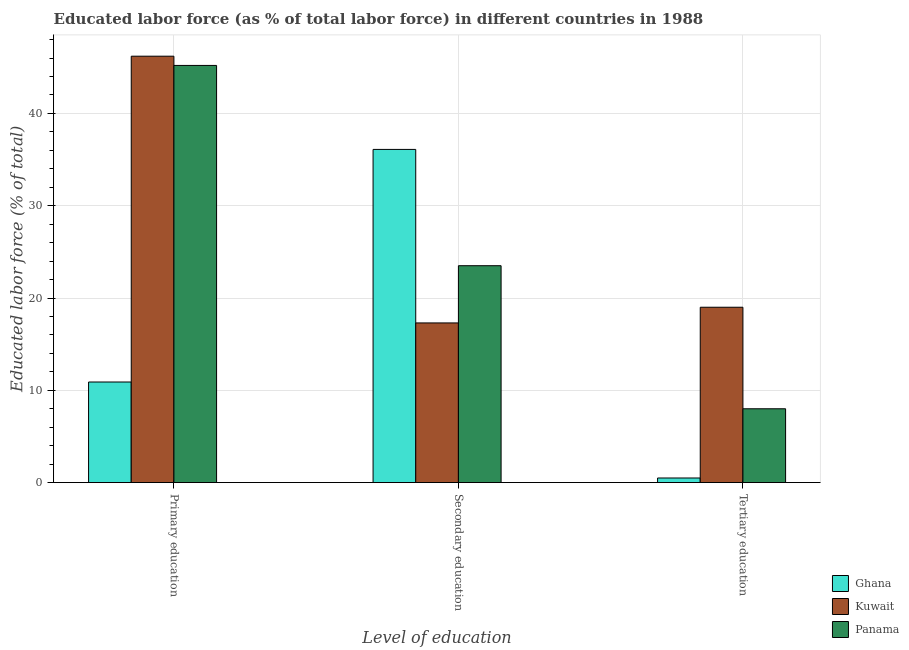How many different coloured bars are there?
Your response must be concise. 3. Are the number of bars per tick equal to the number of legend labels?
Ensure brevity in your answer.  Yes. How many bars are there on the 2nd tick from the left?
Provide a short and direct response. 3. What is the label of the 1st group of bars from the left?
Give a very brief answer. Primary education. What is the percentage of labor force who received primary education in Kuwait?
Offer a very short reply. 46.2. Across all countries, what is the maximum percentage of labor force who received primary education?
Provide a succinct answer. 46.2. Across all countries, what is the minimum percentage of labor force who received tertiary education?
Make the answer very short. 0.5. In which country was the percentage of labor force who received primary education maximum?
Your answer should be very brief. Kuwait. What is the average percentage of labor force who received secondary education per country?
Provide a succinct answer. 25.63. What is the difference between the percentage of labor force who received tertiary education and percentage of labor force who received primary education in Ghana?
Offer a terse response. -10.4. What is the ratio of the percentage of labor force who received primary education in Kuwait to that in Ghana?
Provide a succinct answer. 4.24. Is the percentage of labor force who received primary education in Ghana less than that in Kuwait?
Offer a very short reply. Yes. Is the difference between the percentage of labor force who received secondary education in Kuwait and Panama greater than the difference between the percentage of labor force who received tertiary education in Kuwait and Panama?
Your answer should be very brief. No. What is the difference between the highest and the lowest percentage of labor force who received tertiary education?
Give a very brief answer. 18.5. What does the 2nd bar from the left in Tertiary education represents?
Offer a very short reply. Kuwait. What does the 1st bar from the right in Primary education represents?
Provide a short and direct response. Panama. Are the values on the major ticks of Y-axis written in scientific E-notation?
Your answer should be compact. No. Does the graph contain any zero values?
Provide a succinct answer. No. How many legend labels are there?
Provide a succinct answer. 3. What is the title of the graph?
Provide a succinct answer. Educated labor force (as % of total labor force) in different countries in 1988. What is the label or title of the X-axis?
Ensure brevity in your answer.  Level of education. What is the label or title of the Y-axis?
Provide a short and direct response. Educated labor force (% of total). What is the Educated labor force (% of total) of Ghana in Primary education?
Make the answer very short. 10.9. What is the Educated labor force (% of total) of Kuwait in Primary education?
Offer a very short reply. 46.2. What is the Educated labor force (% of total) of Panama in Primary education?
Your response must be concise. 45.2. What is the Educated labor force (% of total) in Ghana in Secondary education?
Your answer should be very brief. 36.1. What is the Educated labor force (% of total) in Kuwait in Secondary education?
Your answer should be compact. 17.3. What is the Educated labor force (% of total) in Panama in Secondary education?
Your response must be concise. 23.5. Across all Level of education, what is the maximum Educated labor force (% of total) of Ghana?
Your answer should be very brief. 36.1. Across all Level of education, what is the maximum Educated labor force (% of total) of Kuwait?
Your answer should be very brief. 46.2. Across all Level of education, what is the maximum Educated labor force (% of total) in Panama?
Keep it short and to the point. 45.2. Across all Level of education, what is the minimum Educated labor force (% of total) in Kuwait?
Offer a very short reply. 17.3. Across all Level of education, what is the minimum Educated labor force (% of total) in Panama?
Provide a succinct answer. 8. What is the total Educated labor force (% of total) in Ghana in the graph?
Provide a succinct answer. 47.5. What is the total Educated labor force (% of total) in Kuwait in the graph?
Your response must be concise. 82.5. What is the total Educated labor force (% of total) of Panama in the graph?
Give a very brief answer. 76.7. What is the difference between the Educated labor force (% of total) of Ghana in Primary education and that in Secondary education?
Offer a terse response. -25.2. What is the difference between the Educated labor force (% of total) of Kuwait in Primary education and that in Secondary education?
Your answer should be compact. 28.9. What is the difference between the Educated labor force (% of total) in Panama in Primary education and that in Secondary education?
Your answer should be compact. 21.7. What is the difference between the Educated labor force (% of total) in Kuwait in Primary education and that in Tertiary education?
Provide a succinct answer. 27.2. What is the difference between the Educated labor force (% of total) of Panama in Primary education and that in Tertiary education?
Offer a very short reply. 37.2. What is the difference between the Educated labor force (% of total) of Ghana in Secondary education and that in Tertiary education?
Your answer should be very brief. 35.6. What is the difference between the Educated labor force (% of total) of Kuwait in Secondary education and that in Tertiary education?
Offer a terse response. -1.7. What is the difference between the Educated labor force (% of total) of Panama in Secondary education and that in Tertiary education?
Offer a terse response. 15.5. What is the difference between the Educated labor force (% of total) in Kuwait in Primary education and the Educated labor force (% of total) in Panama in Secondary education?
Your answer should be very brief. 22.7. What is the difference between the Educated labor force (% of total) in Kuwait in Primary education and the Educated labor force (% of total) in Panama in Tertiary education?
Offer a very short reply. 38.2. What is the difference between the Educated labor force (% of total) of Ghana in Secondary education and the Educated labor force (% of total) of Kuwait in Tertiary education?
Offer a terse response. 17.1. What is the difference between the Educated labor force (% of total) in Ghana in Secondary education and the Educated labor force (% of total) in Panama in Tertiary education?
Offer a very short reply. 28.1. What is the average Educated labor force (% of total) of Ghana per Level of education?
Offer a very short reply. 15.83. What is the average Educated labor force (% of total) in Kuwait per Level of education?
Offer a very short reply. 27.5. What is the average Educated labor force (% of total) of Panama per Level of education?
Offer a very short reply. 25.57. What is the difference between the Educated labor force (% of total) in Ghana and Educated labor force (% of total) in Kuwait in Primary education?
Ensure brevity in your answer.  -35.3. What is the difference between the Educated labor force (% of total) of Ghana and Educated labor force (% of total) of Panama in Primary education?
Offer a very short reply. -34.3. What is the difference between the Educated labor force (% of total) of Ghana and Educated labor force (% of total) of Kuwait in Tertiary education?
Your answer should be compact. -18.5. What is the difference between the Educated labor force (% of total) in Ghana and Educated labor force (% of total) in Panama in Tertiary education?
Your answer should be very brief. -7.5. What is the difference between the Educated labor force (% of total) in Kuwait and Educated labor force (% of total) in Panama in Tertiary education?
Keep it short and to the point. 11. What is the ratio of the Educated labor force (% of total) in Ghana in Primary education to that in Secondary education?
Provide a short and direct response. 0.3. What is the ratio of the Educated labor force (% of total) of Kuwait in Primary education to that in Secondary education?
Offer a terse response. 2.67. What is the ratio of the Educated labor force (% of total) in Panama in Primary education to that in Secondary education?
Your answer should be compact. 1.92. What is the ratio of the Educated labor force (% of total) of Ghana in Primary education to that in Tertiary education?
Make the answer very short. 21.8. What is the ratio of the Educated labor force (% of total) of Kuwait in Primary education to that in Tertiary education?
Give a very brief answer. 2.43. What is the ratio of the Educated labor force (% of total) in Panama in Primary education to that in Tertiary education?
Offer a very short reply. 5.65. What is the ratio of the Educated labor force (% of total) in Ghana in Secondary education to that in Tertiary education?
Your answer should be compact. 72.2. What is the ratio of the Educated labor force (% of total) of Kuwait in Secondary education to that in Tertiary education?
Offer a terse response. 0.91. What is the ratio of the Educated labor force (% of total) of Panama in Secondary education to that in Tertiary education?
Give a very brief answer. 2.94. What is the difference between the highest and the second highest Educated labor force (% of total) of Ghana?
Your answer should be very brief. 25.2. What is the difference between the highest and the second highest Educated labor force (% of total) in Kuwait?
Offer a terse response. 27.2. What is the difference between the highest and the second highest Educated labor force (% of total) of Panama?
Offer a terse response. 21.7. What is the difference between the highest and the lowest Educated labor force (% of total) of Ghana?
Offer a very short reply. 35.6. What is the difference between the highest and the lowest Educated labor force (% of total) in Kuwait?
Your answer should be very brief. 28.9. What is the difference between the highest and the lowest Educated labor force (% of total) in Panama?
Offer a terse response. 37.2. 